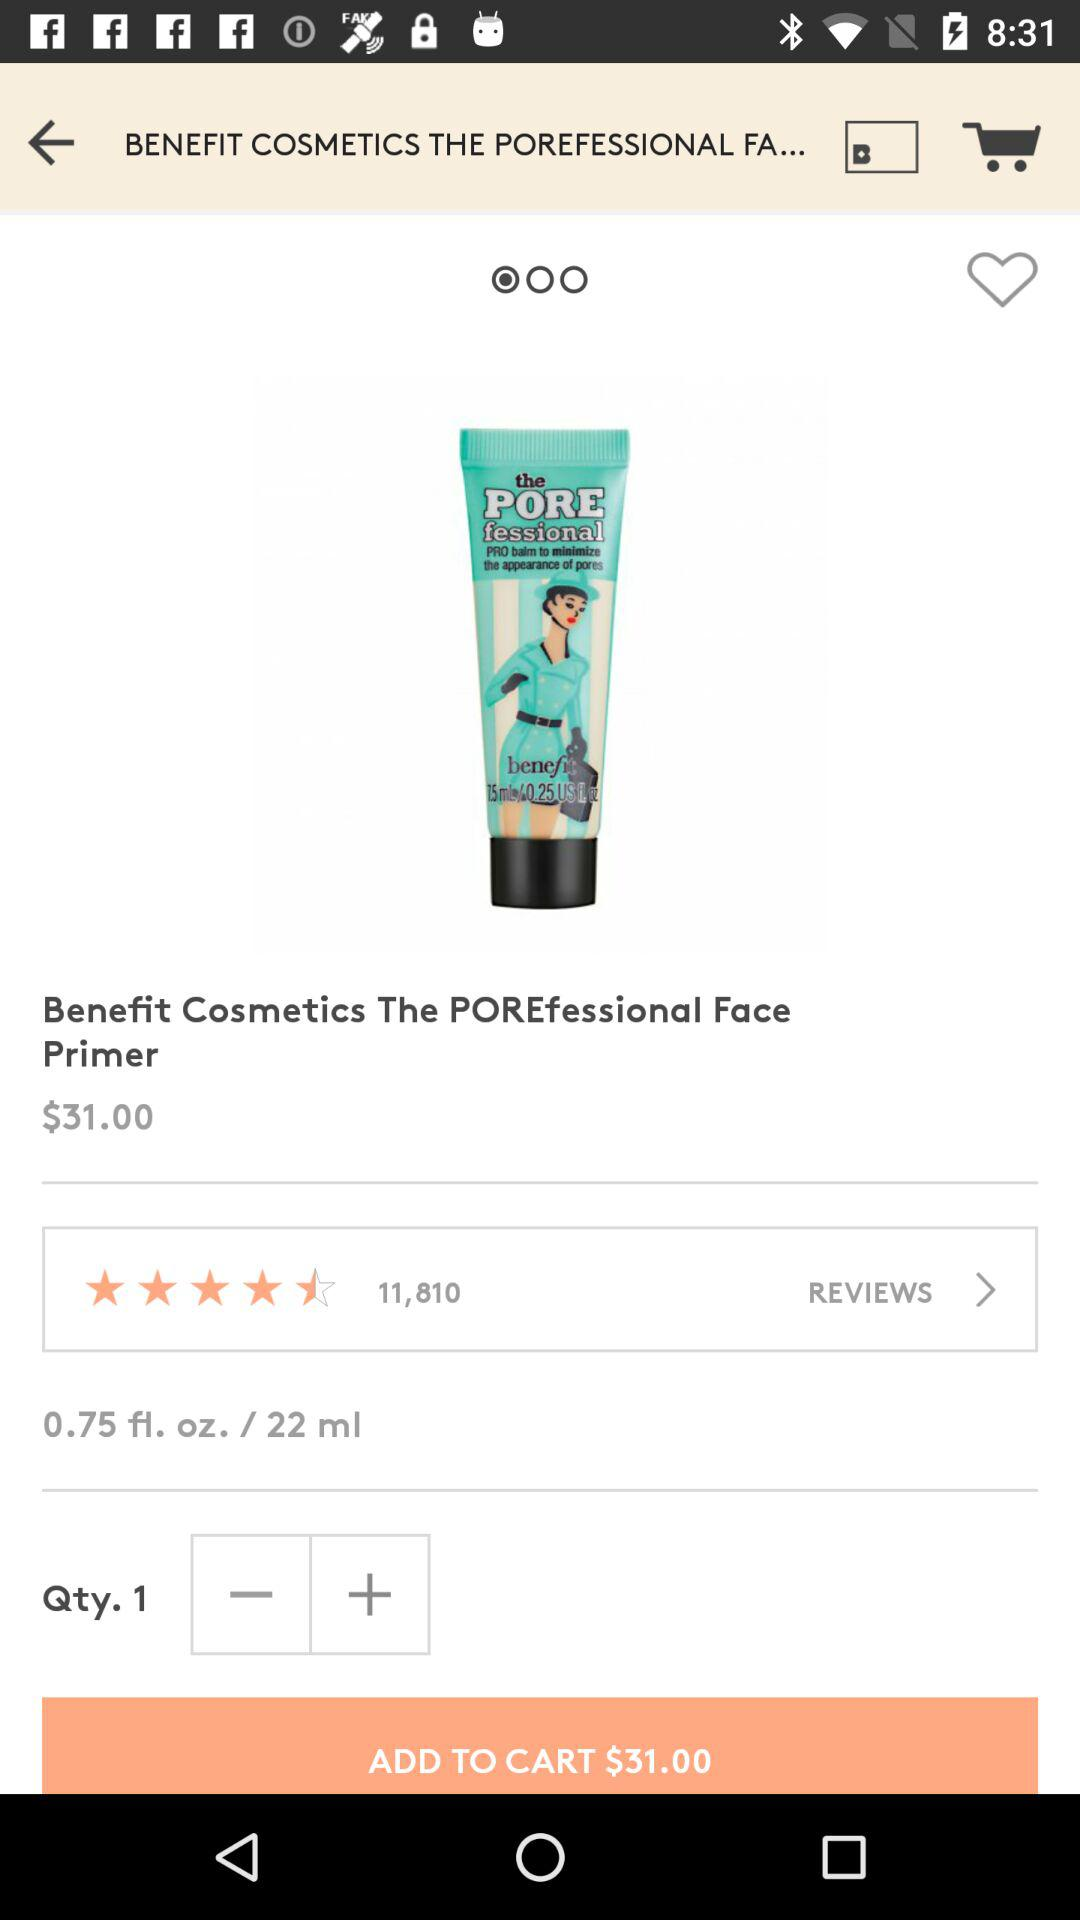What is the volume of the product? The volume of the product is 0.75 fluid ounces or 22 ml. 